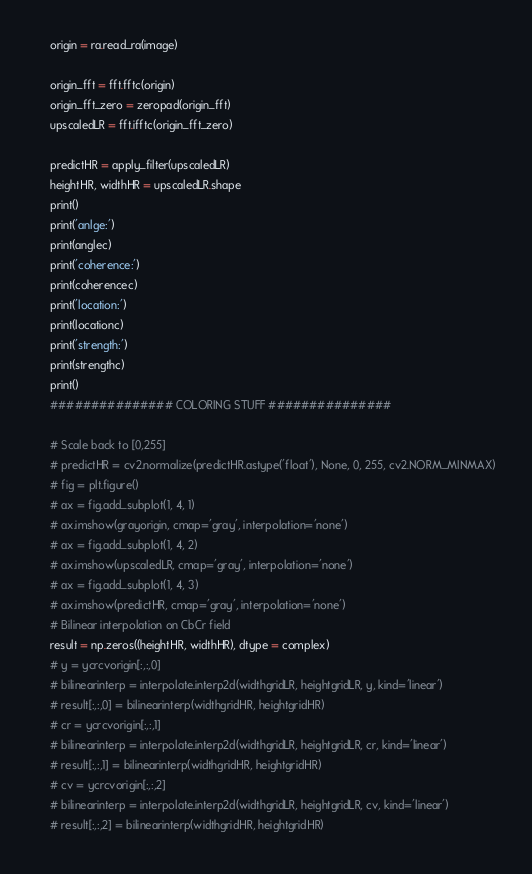<code> <loc_0><loc_0><loc_500><loc_500><_Python_>    origin = ra.read_ra(image)

    origin_fft = fft.fftc(origin)
    origin_fft_zero = zeropad(origin_fft)
    upscaledLR = fft.ifftc(origin_fft_zero)

    predictHR = apply_filter(upscaledLR)
    heightHR, widthHR = upscaledLR.shape
    print()
    print('anlge:')
    print(anglec)
    print('coherence:')
    print(coherencec)
    print('location:')
    print(locationc)
    print('strength:')
    print(strengthc)
    print()
    ############### COLORING STUFF ###############
    
    # Scale back to [0,255]
    # predictHR = cv2.normalize(predictHR.astype('float'), None, 0, 255, cv2.NORM_MINMAX)
    # fig = plt.figure()
    # ax = fig.add_subplot(1, 4, 1)
    # ax.imshow(grayorigin, cmap='gray', interpolation='none')
    # ax = fig.add_subplot(1, 4, 2)
    # ax.imshow(upscaledLR, cmap='gray', interpolation='none')
    # ax = fig.add_subplot(1, 4, 3)
    # ax.imshow(predictHR, cmap='gray', interpolation='none')
    # Bilinear interpolation on CbCr field
    result = np.zeros((heightHR, widthHR), dtype = complex)
    # y = ycrcvorigin[:,:,0]
    # bilinearinterp = interpolate.interp2d(widthgridLR, heightgridLR, y, kind='linear')
    # result[:,:,0] = bilinearinterp(widthgridHR, heightgridHR)
    # cr = ycrcvorigin[:,:,1]
    # bilinearinterp = interpolate.interp2d(widthgridLR, heightgridLR, cr, kind='linear')
    # result[:,:,1] = bilinearinterp(widthgridHR, heightgridHR)
    # cv = ycrcvorigin[:,:,2]
    # bilinearinterp = interpolate.interp2d(widthgridLR, heightgridLR, cv, kind='linear')
    # result[:,:,2] = bilinearinterp(widthgridHR, heightgridHR)</code> 